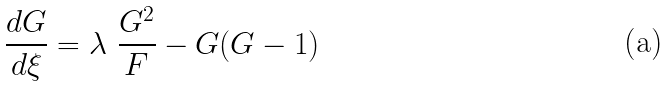<formula> <loc_0><loc_0><loc_500><loc_500>\frac { d G } { d \xi } = \lambda \ \frac { G ^ { 2 } } { F } - G ( G - 1 )</formula> 